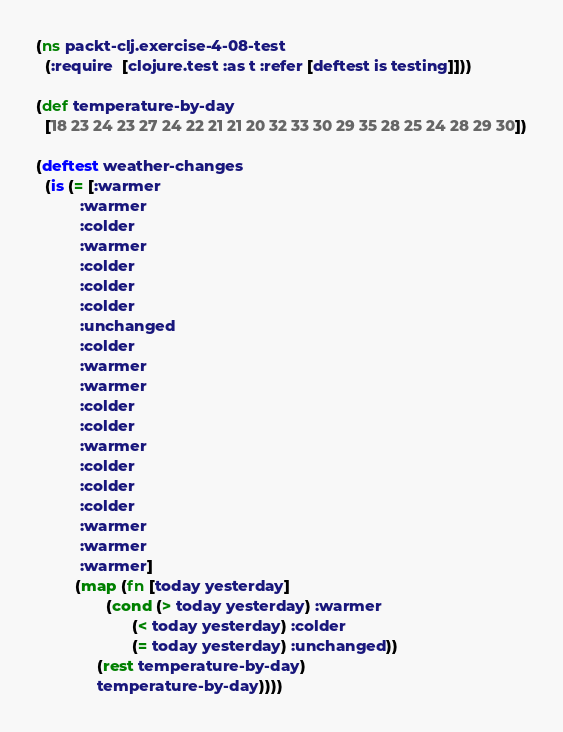Convert code to text. <code><loc_0><loc_0><loc_500><loc_500><_Clojure_>(ns packt-clj.exercise-4-08-test
  (:require  [clojure.test :as t :refer [deftest is testing]]))

(def temperature-by-day
  [18 23 24 23 27 24 22 21 21 20 32 33 30 29 35 28 25 24 28 29 30])

(deftest weather-changes
  (is (= [:warmer          
          :warmer
          :colder
          :warmer
          :colder
          :colder
          :colder
          :unchanged
          :colder
          :warmer
          :warmer
          :colder
          :colder
          :warmer
          :colder
          :colder
          :colder
          :warmer
          :warmer
          :warmer]
         (map (fn [today yesterday] 
                (cond (> today yesterday) :warmer
                      (< today yesterday) :colder
                      (= today yesterday) :unchanged))
              (rest temperature-by-day)
              temperature-by-day))))

</code> 